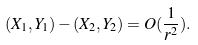<formula> <loc_0><loc_0><loc_500><loc_500>( X _ { 1 } , Y _ { 1 } ) - ( X _ { 2 } , Y _ { 2 } ) = O ( \frac { 1 } { r ^ { 2 } } ) .</formula> 